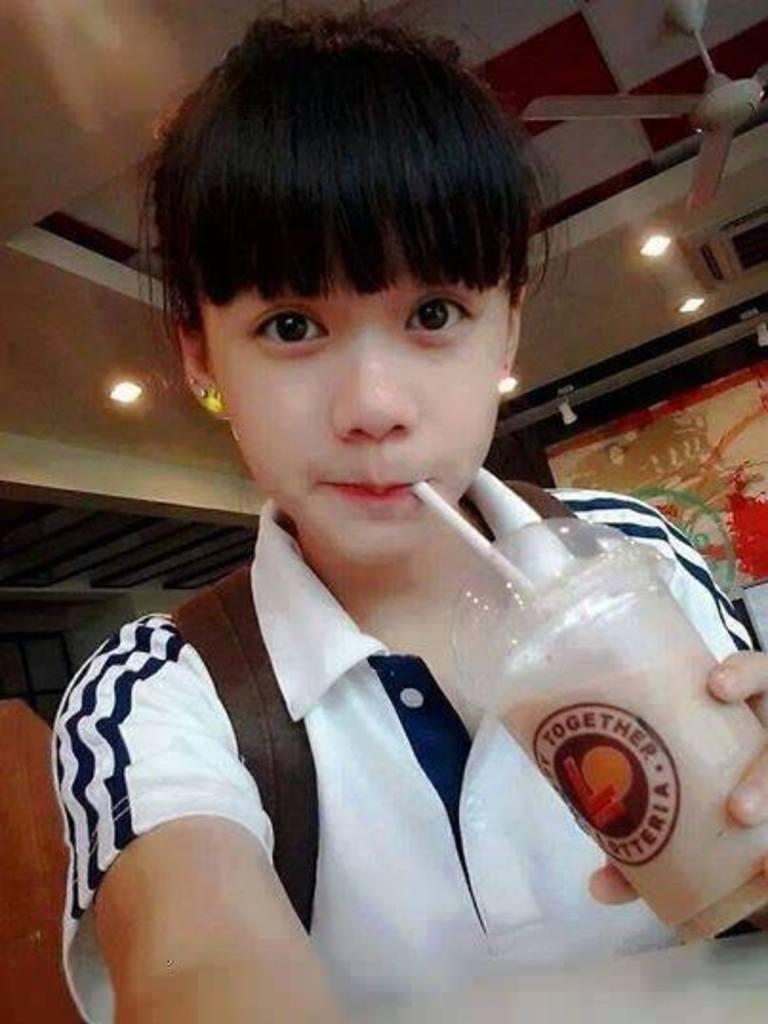In one or two sentences, can you explain what this image depicts? In the picture I can see one girl is sitting and holding the object. At the top of the image I can see the fan and lights. 